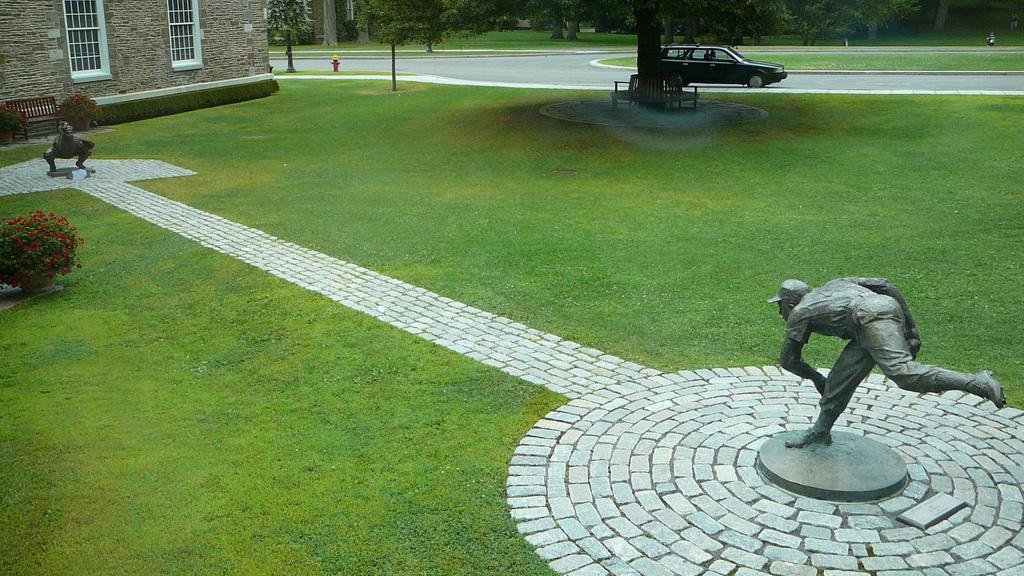What type of artwork can be seen in the image? There are sculptures in the image. What else is visible on the road in the image? There is a vehicle on the road in the image. What type of seating is available in the image? There are benches in the image. What type of vegetation is present in the image? There are plants and trees in the image. What type of structure is visible with windows in the image? There is a wall with windows in the image. What type of safety equipment is present in the image? There is a fire hydrant in the image. What type of nut is being used to coat the sculptures in the image? There is no mention of nuts or coating in the image; the sculptures are not described as having any such treatment. 